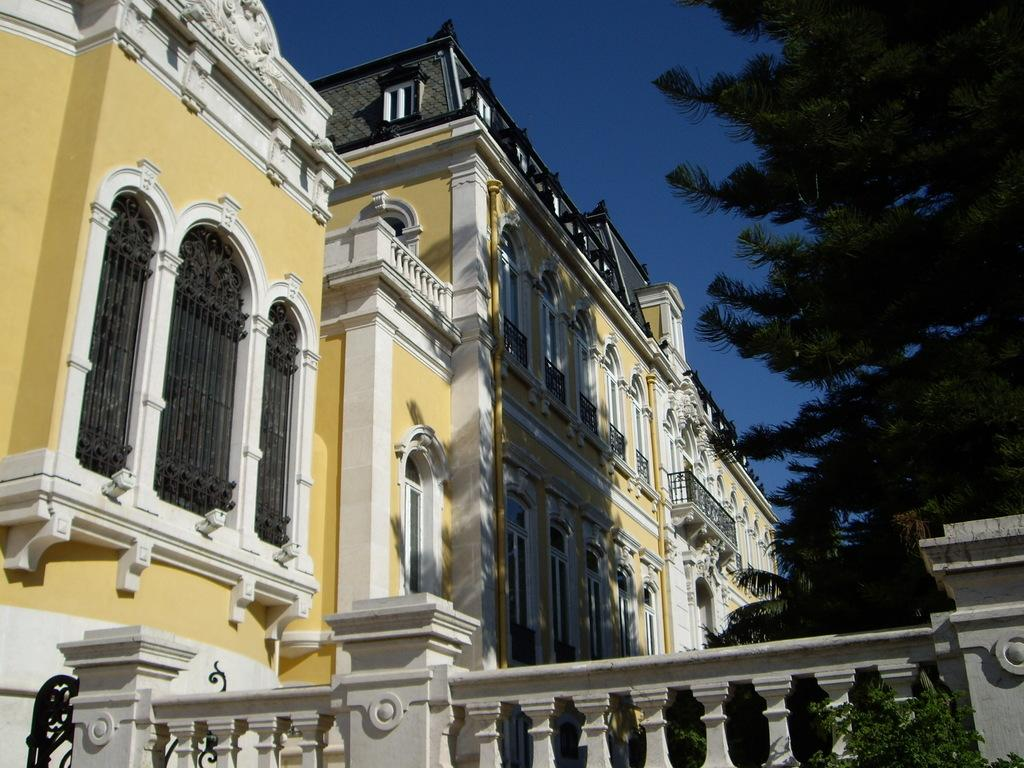What can be seen in the foreground of the image? There is railing in the foreground of the image. What type of vegetation is on the right side of the image? There are trees on the right side of the image. What type of structures are visible on the left side and towards the center of the image? There are buildings on the left side and towards the center of the image. What is visible at the top of the image? The sky is visible at the top of the image. What type of treatment is being administered to the trees on the right side of the image? There is no indication of any treatment being administered to the trees in the image; they are simply visible in the image. What type of flag is flying over the buildings in the image? There is no flag visible in the image; only the buildings, trees, railing, and sky are present. 